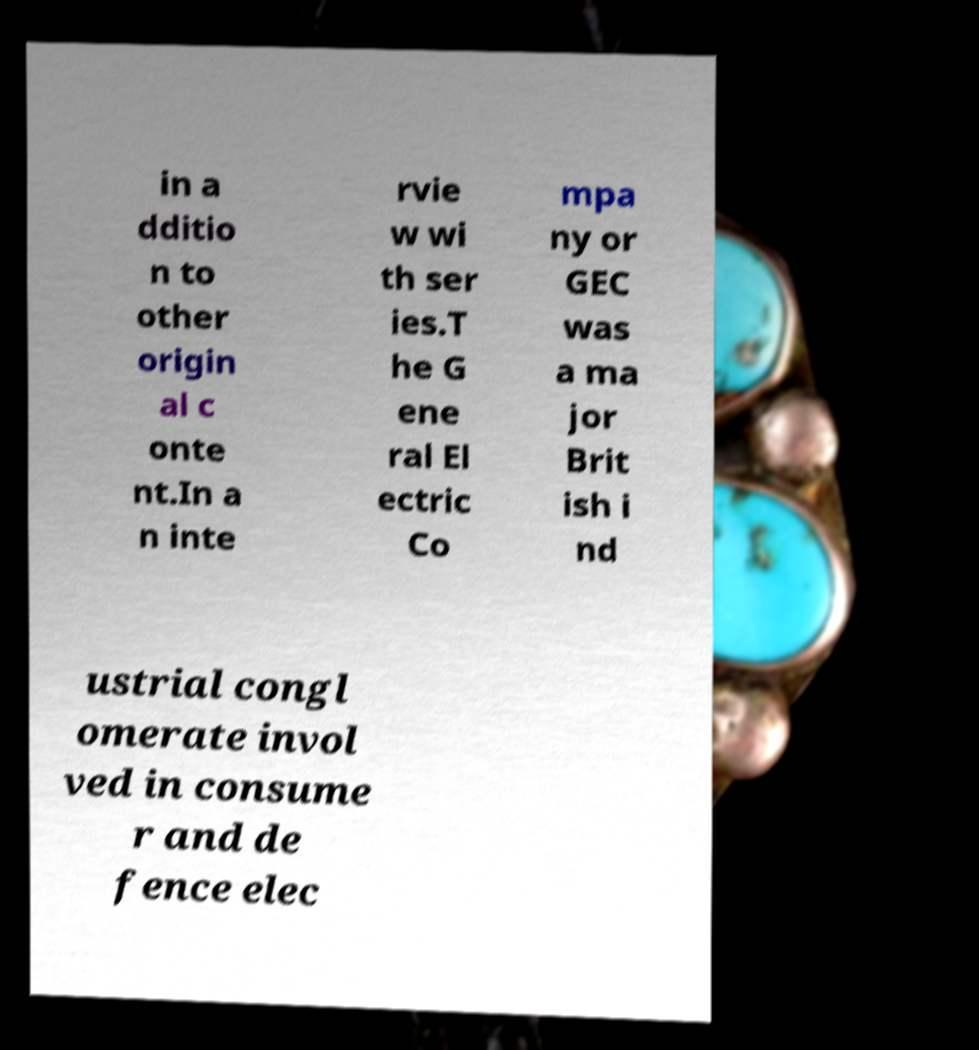What messages or text are displayed in this image? I need them in a readable, typed format. in a dditio n to other origin al c onte nt.In a n inte rvie w wi th ser ies.T he G ene ral El ectric Co mpa ny or GEC was a ma jor Brit ish i nd ustrial congl omerate invol ved in consume r and de fence elec 